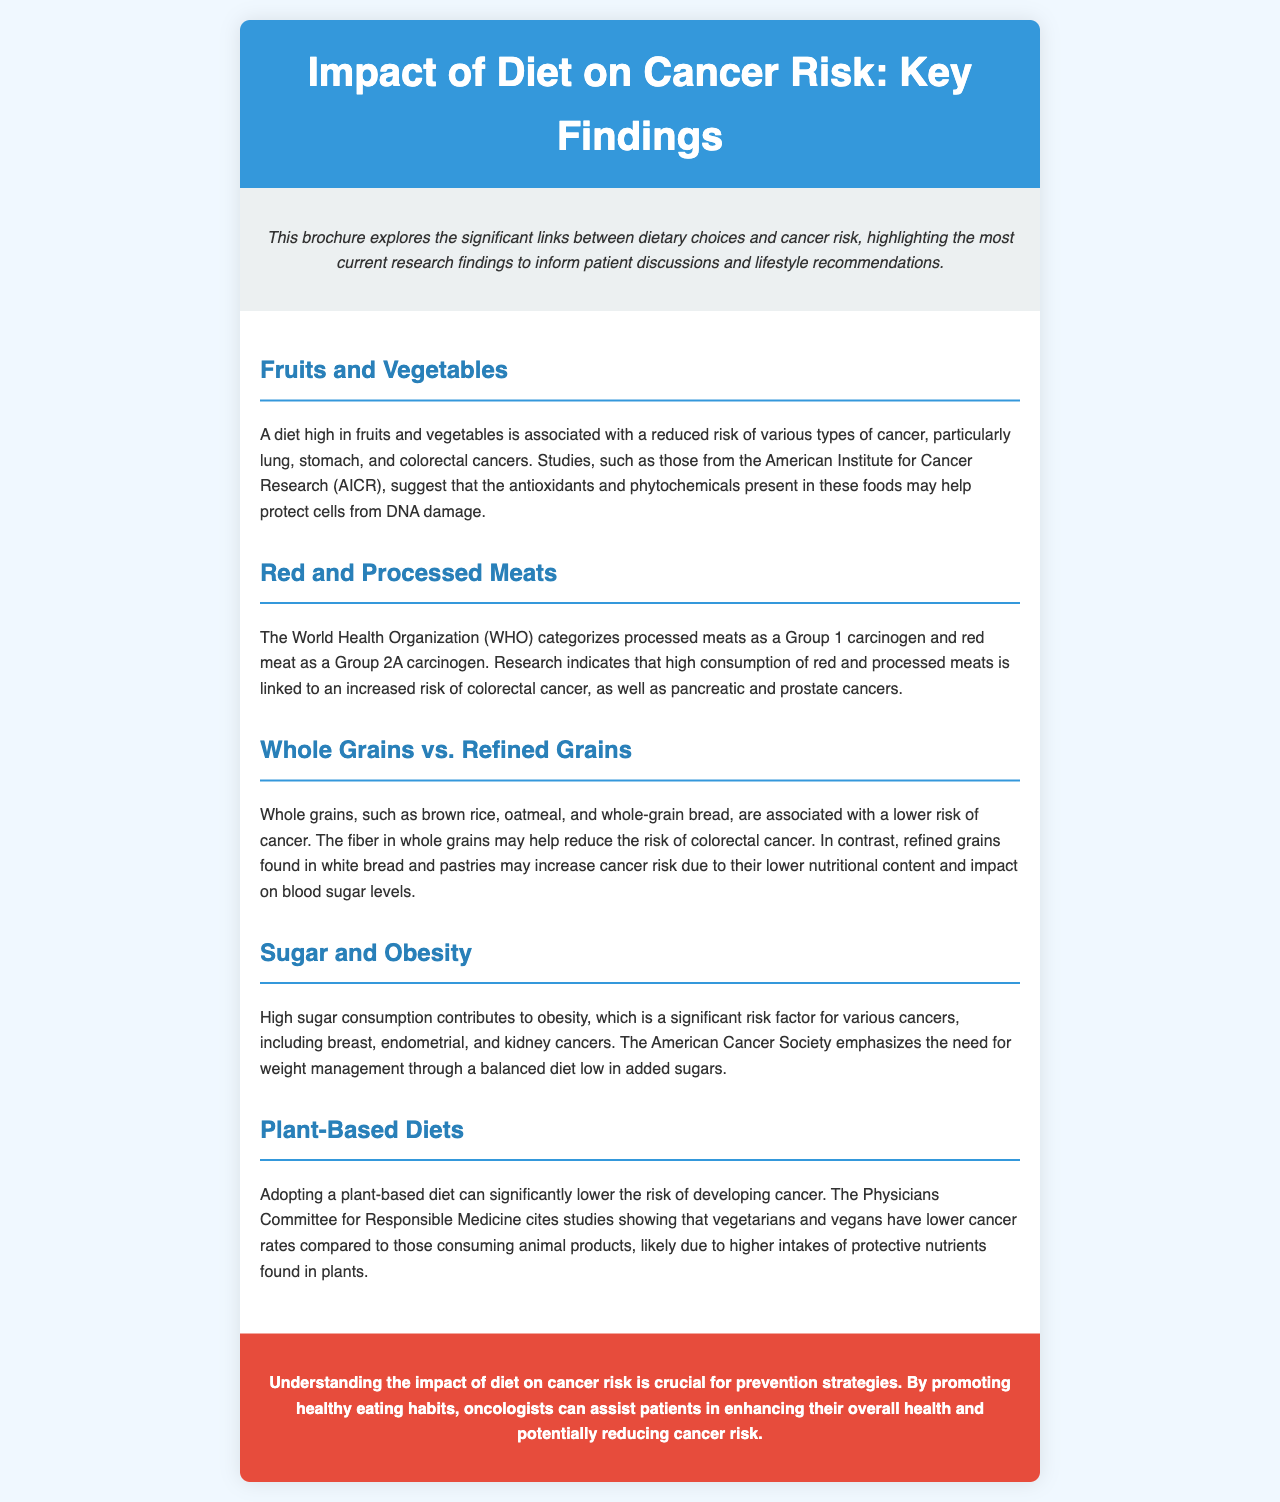What are the types of cancer associated with high fruit and vegetable intake? The document lists lung, stomach, and colorectal cancers as cancer types linked to high fruit and vegetable consumption.
Answer: lung, stomach, colorectal What organization categorizes processed meats as a Group 1 carcinogen? The World Health Organization (WHO) is identified as the organization that categorizes processed meats this way in the document.
Answer: WHO What is advised for weight management according to the American Cancer Society? The document states that a balanced diet low in added sugars is advised for weight management.
Answer: balanced diet low in added sugars What types of grains are suggested to lower cancer risk? Whole grains, such as brown rice, oatmeal, and whole-grain bread, are suggested to reduce cancer risk in the document.
Answer: whole grains How does a plant-based diet affect cancer rates? The brochure indicates that a plant-based diet can significantly lower cancer rates as per studies mentioned.
Answer: significantly lower What is the primary reason for the risk associated with refined grains? The document states that refined grains may increase cancer risk due to their lower nutritional content and impact on blood sugar levels.
Answer: lower nutritional content What stance does the brochure take on sugar consumption? It asserts that high sugar consumption contributes to obesity, a significant cancer risk factor.
Answer: contributes to obesity What is the main objective of understanding diet's impact on cancer risk according to the brochure? The brochure emphasizes that promoting healthy eating habits is crucial for prevention strategies.
Answer: prevention strategies 